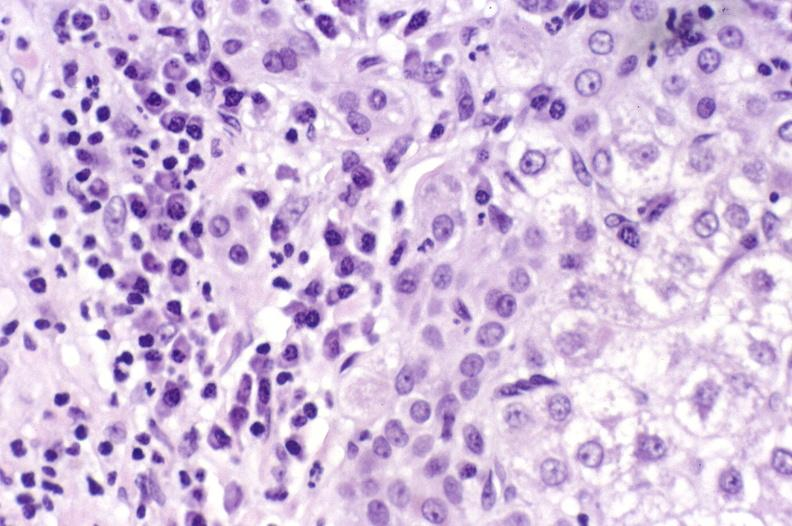s liver present?
Answer the question using a single word or phrase. Yes 